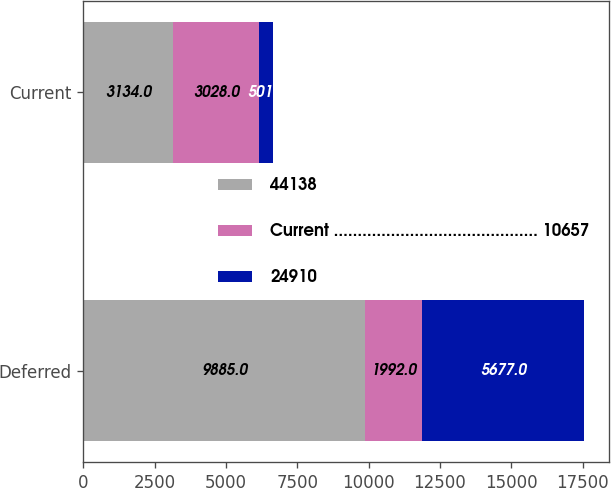Convert chart to OTSL. <chart><loc_0><loc_0><loc_500><loc_500><stacked_bar_chart><ecel><fcel>Deferred<fcel>Current<nl><fcel>44138<fcel>9885<fcel>3134<nl><fcel>Current ........................................... 10657<fcel>1992<fcel>3028<nl><fcel>24910<fcel>5677<fcel>501<nl></chart> 